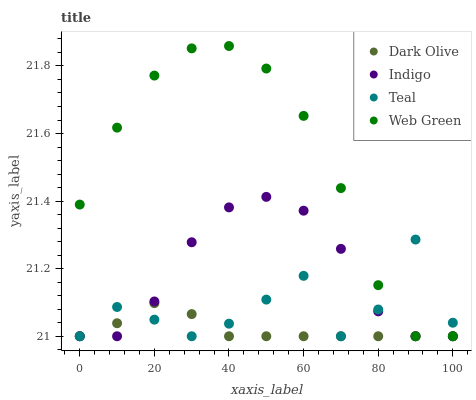Does Dark Olive have the minimum area under the curve?
Answer yes or no. Yes. Does Web Green have the maximum area under the curve?
Answer yes or no. Yes. Does Indigo have the minimum area under the curve?
Answer yes or no. No. Does Indigo have the maximum area under the curve?
Answer yes or no. No. Is Dark Olive the smoothest?
Answer yes or no. Yes. Is Teal the roughest?
Answer yes or no. Yes. Is Indigo the smoothest?
Answer yes or no. No. Is Indigo the roughest?
Answer yes or no. No. Does Dark Olive have the lowest value?
Answer yes or no. Yes. Does Web Green have the highest value?
Answer yes or no. Yes. Does Indigo have the highest value?
Answer yes or no. No. Does Web Green intersect Teal?
Answer yes or no. Yes. Is Web Green less than Teal?
Answer yes or no. No. Is Web Green greater than Teal?
Answer yes or no. No. 